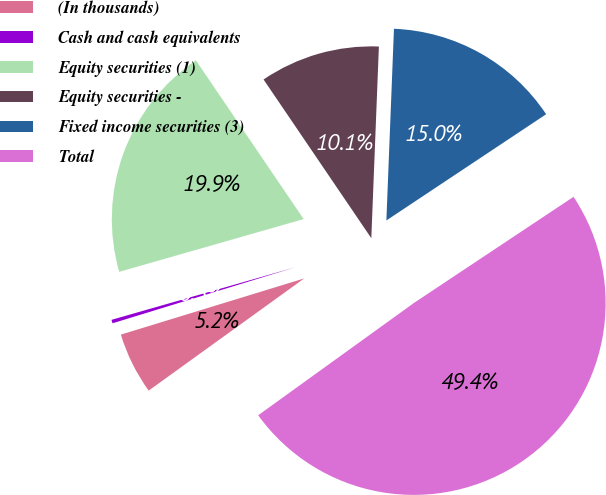Convert chart. <chart><loc_0><loc_0><loc_500><loc_500><pie_chart><fcel>(In thousands)<fcel>Cash and cash equivalents<fcel>Equity securities (1)<fcel>Equity securities -<fcel>Fixed income securities (3)<fcel>Total<nl><fcel>5.21%<fcel>0.3%<fcel>19.94%<fcel>10.12%<fcel>15.03%<fcel>49.39%<nl></chart> 